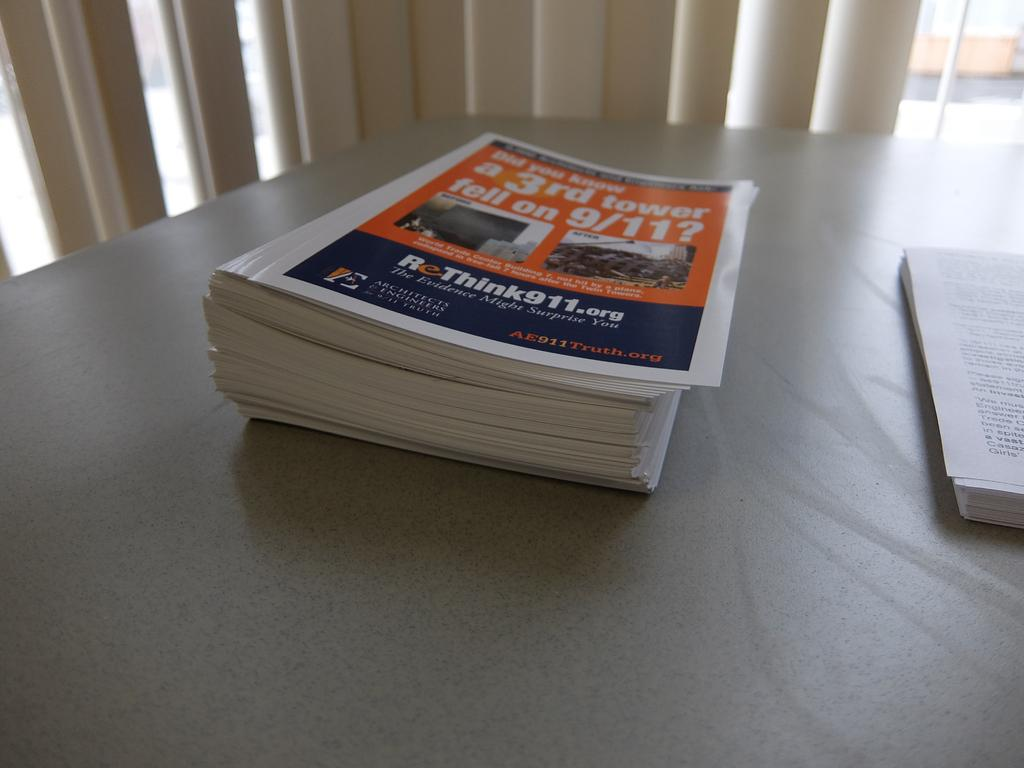<image>
Offer a succinct explanation of the picture presented. A stack of pamphlets from ReThink911.com lie on a counter. 